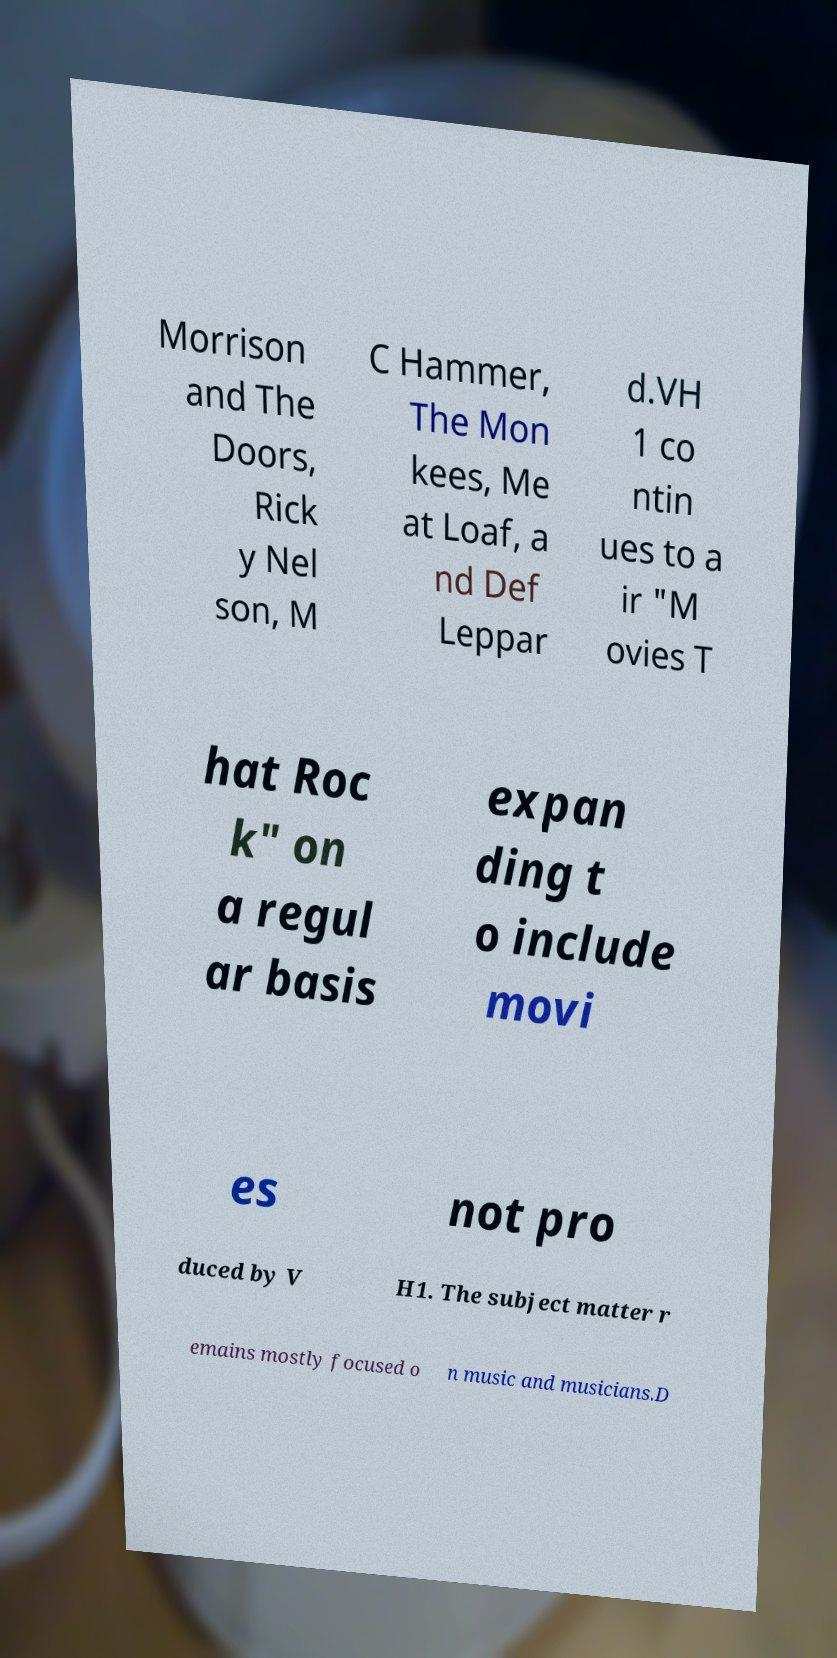Could you assist in decoding the text presented in this image and type it out clearly? Morrison and The Doors, Rick y Nel son, M C Hammer, The Mon kees, Me at Loaf, a nd Def Leppar d.VH 1 co ntin ues to a ir "M ovies T hat Roc k" on a regul ar basis expan ding t o include movi es not pro duced by V H1. The subject matter r emains mostly focused o n music and musicians.D 